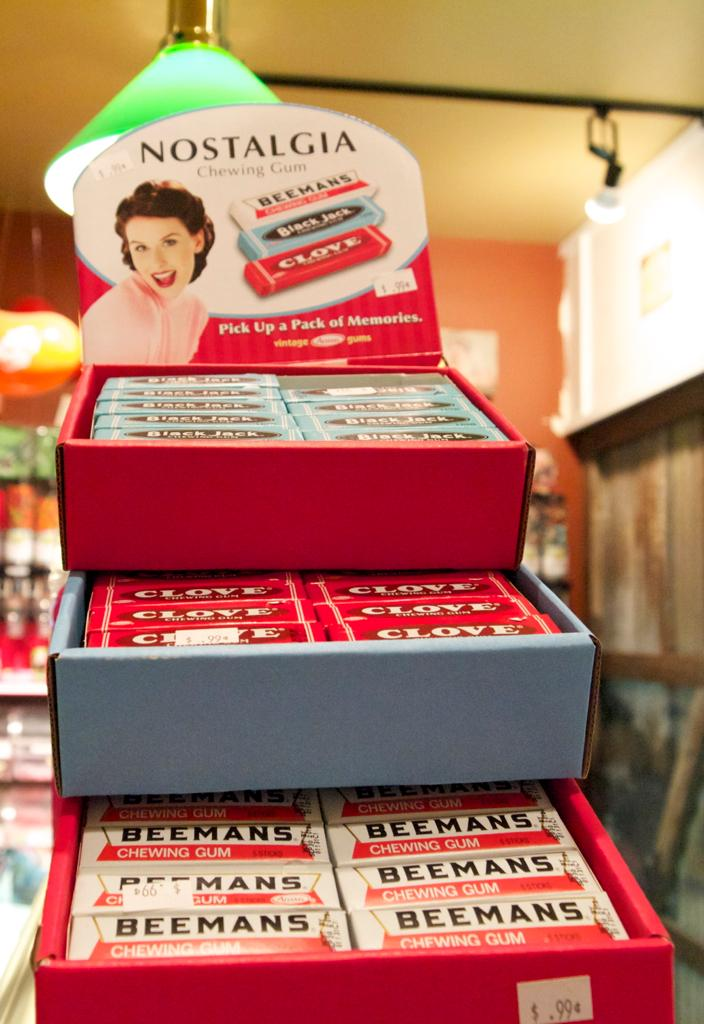<image>
Render a clear and concise summary of the photo. A display box of Beemans gum says "Nostalgia" at the top. 